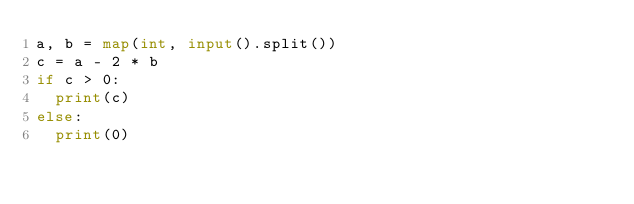<code> <loc_0><loc_0><loc_500><loc_500><_Python_>a, b = map(int, input().split())
c = a - 2 * b
if c > 0:
  print(c)
else:
  print(0)</code> 